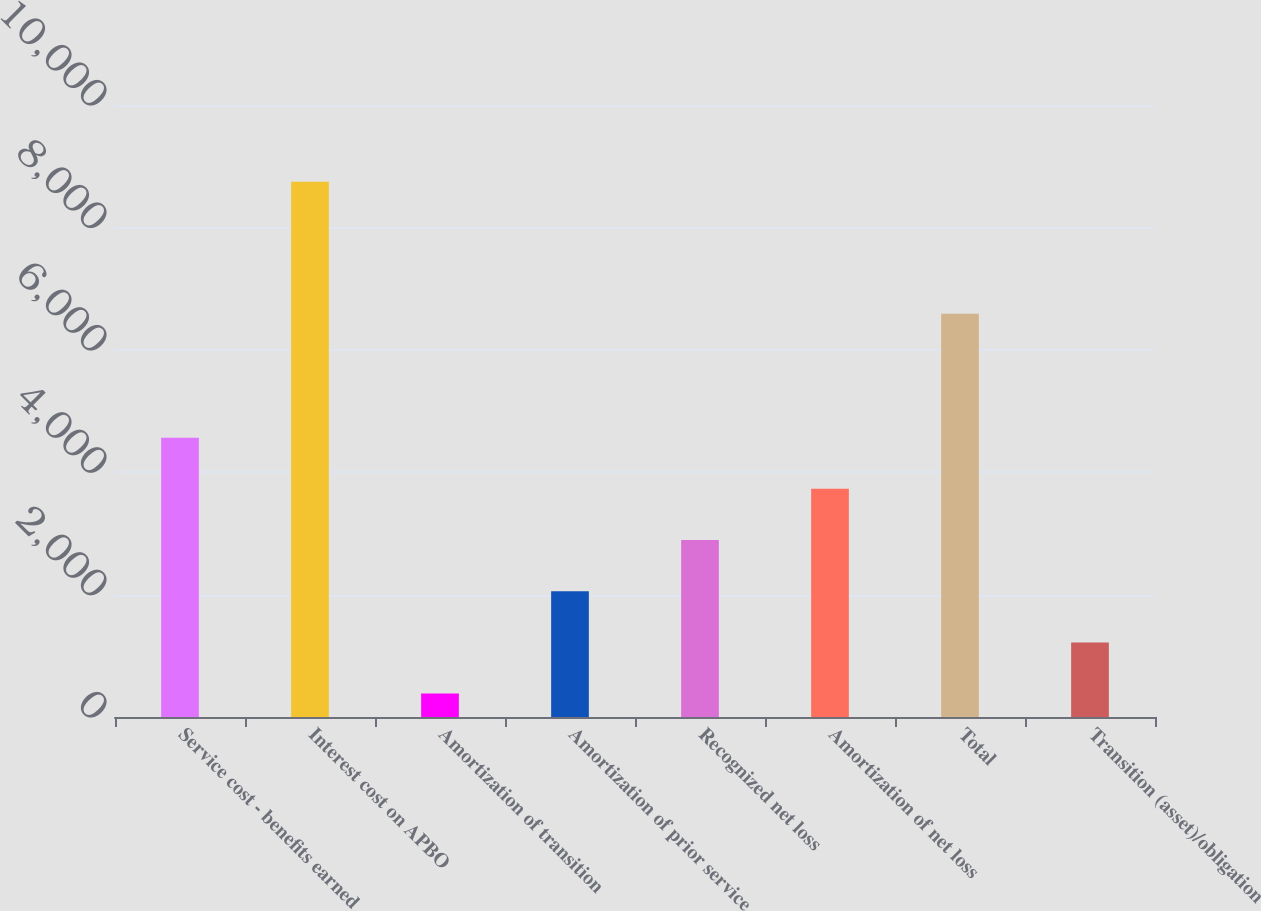Convert chart. <chart><loc_0><loc_0><loc_500><loc_500><bar_chart><fcel>Service cost - benefits earned<fcel>Interest cost on APBO<fcel>Amortization of transition<fcel>Amortization of prior service<fcel>Recognized net loss<fcel>Amortization of net loss<fcel>Total<fcel>Transition (asset)/obligation<nl><fcel>4564<fcel>8746<fcel>382<fcel>2054.8<fcel>2891.2<fcel>3727.6<fcel>6588<fcel>1218.4<nl></chart> 